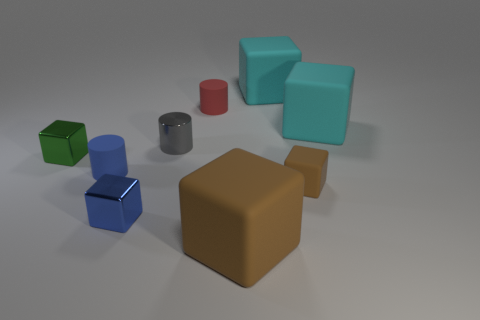What number of rubber objects have the same size as the gray metal cylinder?
Offer a terse response. 3. There is a large matte thing that is the same color as the small rubber block; what is its shape?
Offer a very short reply. Cube. Does the big object in front of the small green block have the same material as the cylinder in front of the green thing?
Offer a very short reply. Yes. What is the color of the shiny cylinder?
Your response must be concise. Gray. What number of green metallic things are the same shape as the small blue rubber thing?
Keep it short and to the point. 0. The rubber cube that is the same size as the gray cylinder is what color?
Provide a short and direct response. Brown. Are there any gray things?
Provide a short and direct response. Yes. What is the shape of the large cyan matte object in front of the red rubber cylinder?
Keep it short and to the point. Cube. What number of objects are both behind the green metal block and right of the gray metal thing?
Your answer should be compact. 3. Are there any tiny blue objects made of the same material as the tiny green thing?
Keep it short and to the point. Yes. 